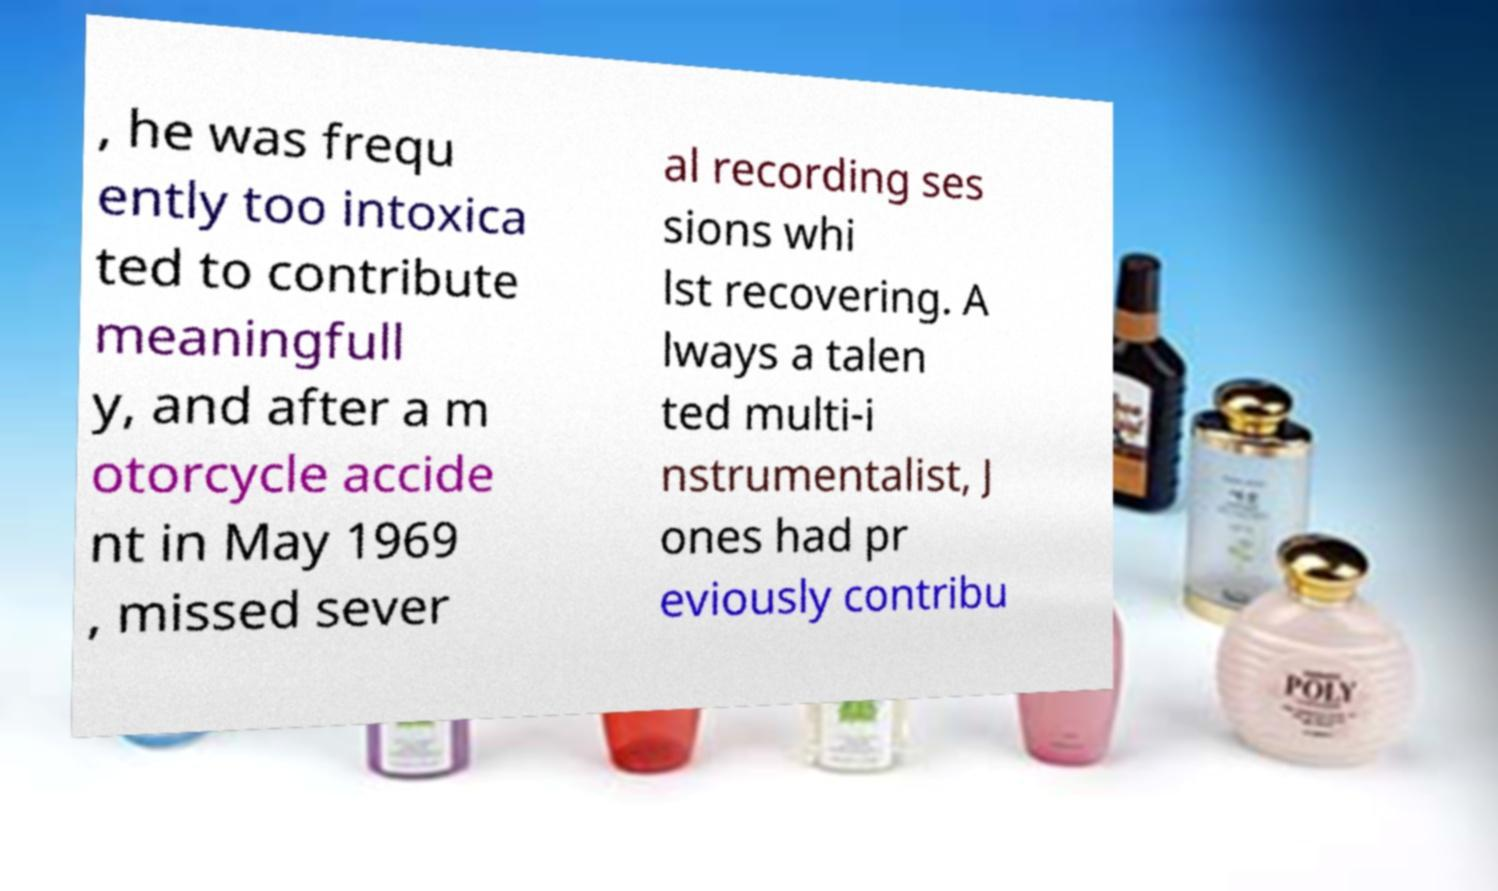Please read and relay the text visible in this image. What does it say? , he was frequ ently too intoxica ted to contribute meaningfull y, and after a m otorcycle accide nt in May 1969 , missed sever al recording ses sions whi lst recovering. A lways a talen ted multi-i nstrumentalist, J ones had pr eviously contribu 